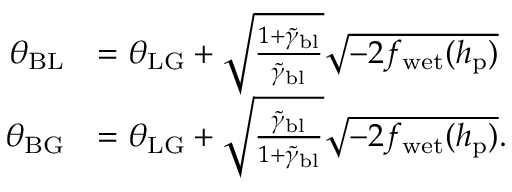Convert formula to latex. <formula><loc_0><loc_0><loc_500><loc_500>\begin{array} { r l } { \theta _ { B L } } & { = \theta _ { L G } + \sqrt { \frac { 1 + \tilde { \gamma } _ { b l } } { \tilde { \gamma } _ { b l } } } \sqrt { - 2 f _ { w e t } ( h _ { p } ) } } \\ { \theta _ { B G } } & { = \theta _ { L G } + \sqrt { \frac { \tilde { \gamma } _ { b l } } { 1 + \tilde { \gamma } _ { b l } } } \sqrt { - 2 f _ { w e t } ( h _ { p } ) } . } \end{array}</formula> 